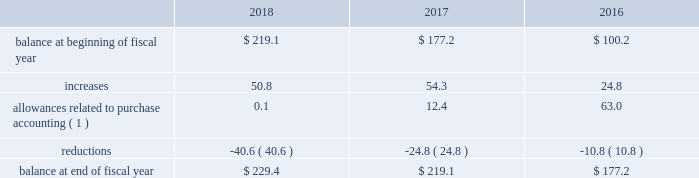Westrock company notes to consolidated financial statements fffd ( continued ) at september 30 , 2018 and september 30 , 2017 , gross net operating losses for foreign reporting purposes of approximately $ 698.4 million and $ 673.7 million , respectively , were available for carryforward .
A majority of these loss carryforwards generally expire between fiscal 2020 and 2038 , while a portion have an indefinite carryforward .
The tax effected values of these net operating losses are $ 185.8 million and $ 182.6 million at september 30 , 2018 and 2017 , respectively , exclusive of valuation allowances of $ 161.5 million and $ 149.6 million at september 30 , 2018 and 2017 , respectively .
At september 30 , 2018 and 2017 , we had state tax credit carryforwards of $ 64.8 million and $ 54.4 million , respectively .
These state tax credit carryforwards generally expire within 5 to 10 years ; however , certain state credits can be carried forward indefinitely .
Valuation allowances of $ 56.1 million and $ 47.3 million at september 30 , 2018 and 2017 , respectively , have been provided on these assets .
These valuation allowances have been recorded due to uncertainty regarding our ability to generate sufficient taxable income in the appropriate taxing jurisdiction .
The table represents a summary of the valuation allowances against deferred tax assets for fiscal 2018 , 2017 and 2016 ( in millions ) : .
( 1 ) amounts in fiscal 2018 and 2017 relate to the mps acquisition .
Adjustments in fiscal 2016 relate to the combination and the sp fiber acquisition .
Consistent with prior years , we consider a portion of our earnings from certain foreign subsidiaries as subject to repatriation and we provide for taxes accordingly .
However , we consider the unremitted earnings and all other outside basis differences from all other foreign subsidiaries to be indefinitely reinvested .
Accordingly , we have not provided for any taxes that would be due .
As of september 30 , 2018 , we estimate our outside basis difference in foreign subsidiaries that are considered indefinitely reinvested to be approximately $ 1.5 billion .
The components of the outside basis difference are comprised of purchase accounting adjustments , undistributed earnings , and equity components .
Except for the portion of our earnings from certain foreign subsidiaries where we provided for taxes , we have not provided for any taxes that would be due upon the reversal of the outside basis differences .
However , in the event of a distribution in the form of dividends or dispositions of the subsidiaries , we may be subject to incremental u.s .
Income taxes , subject to an adjustment for foreign tax credits , and withholding taxes or income taxes payable to the foreign jurisdictions .
As of september 30 , 2018 , the determination of the amount of unrecognized deferred tax liability related to any remaining undistributed foreign earnings not subject to the transition tax and additional outside basis differences is not practicable. .
By what percent did the balance of deferred tax assets increase between 2016 and 2018? 
Computations: ((229.4 - 177.2) / 177.2)
Answer: 0.29458. Westrock company notes to consolidated financial statements fffd ( continued ) at september 30 , 2018 and september 30 , 2017 , gross net operating losses for foreign reporting purposes of approximately $ 698.4 million and $ 673.7 million , respectively , were available for carryforward .
A majority of these loss carryforwards generally expire between fiscal 2020 and 2038 , while a portion have an indefinite carryforward .
The tax effected values of these net operating losses are $ 185.8 million and $ 182.6 million at september 30 , 2018 and 2017 , respectively , exclusive of valuation allowances of $ 161.5 million and $ 149.6 million at september 30 , 2018 and 2017 , respectively .
At september 30 , 2018 and 2017 , we had state tax credit carryforwards of $ 64.8 million and $ 54.4 million , respectively .
These state tax credit carryforwards generally expire within 5 to 10 years ; however , certain state credits can be carried forward indefinitely .
Valuation allowances of $ 56.1 million and $ 47.3 million at september 30 , 2018 and 2017 , respectively , have been provided on these assets .
These valuation allowances have been recorded due to uncertainty regarding our ability to generate sufficient taxable income in the appropriate taxing jurisdiction .
The table represents a summary of the valuation allowances against deferred tax assets for fiscal 2018 , 2017 and 2016 ( in millions ) : .
( 1 ) amounts in fiscal 2018 and 2017 relate to the mps acquisition .
Adjustments in fiscal 2016 relate to the combination and the sp fiber acquisition .
Consistent with prior years , we consider a portion of our earnings from certain foreign subsidiaries as subject to repatriation and we provide for taxes accordingly .
However , we consider the unremitted earnings and all other outside basis differences from all other foreign subsidiaries to be indefinitely reinvested .
Accordingly , we have not provided for any taxes that would be due .
As of september 30 , 2018 , we estimate our outside basis difference in foreign subsidiaries that are considered indefinitely reinvested to be approximately $ 1.5 billion .
The components of the outside basis difference are comprised of purchase accounting adjustments , undistributed earnings , and equity components .
Except for the portion of our earnings from certain foreign subsidiaries where we provided for taxes , we have not provided for any taxes that would be due upon the reversal of the outside basis differences .
However , in the event of a distribution in the form of dividends or dispositions of the subsidiaries , we may be subject to incremental u.s .
Income taxes , subject to an adjustment for foreign tax credits , and withholding taxes or income taxes payable to the foreign jurisdictions .
As of september 30 , 2018 , the determination of the amount of unrecognized deferred tax liability related to any remaining undistributed foreign earnings not subject to the transition tax and additional outside basis differences is not practicable. .
In 2018 what was the percentage change in the valuation allowances against deferred tax assets? 
Computations: ((229.4 - 219.1) / 219.1)
Answer: 0.04701. 